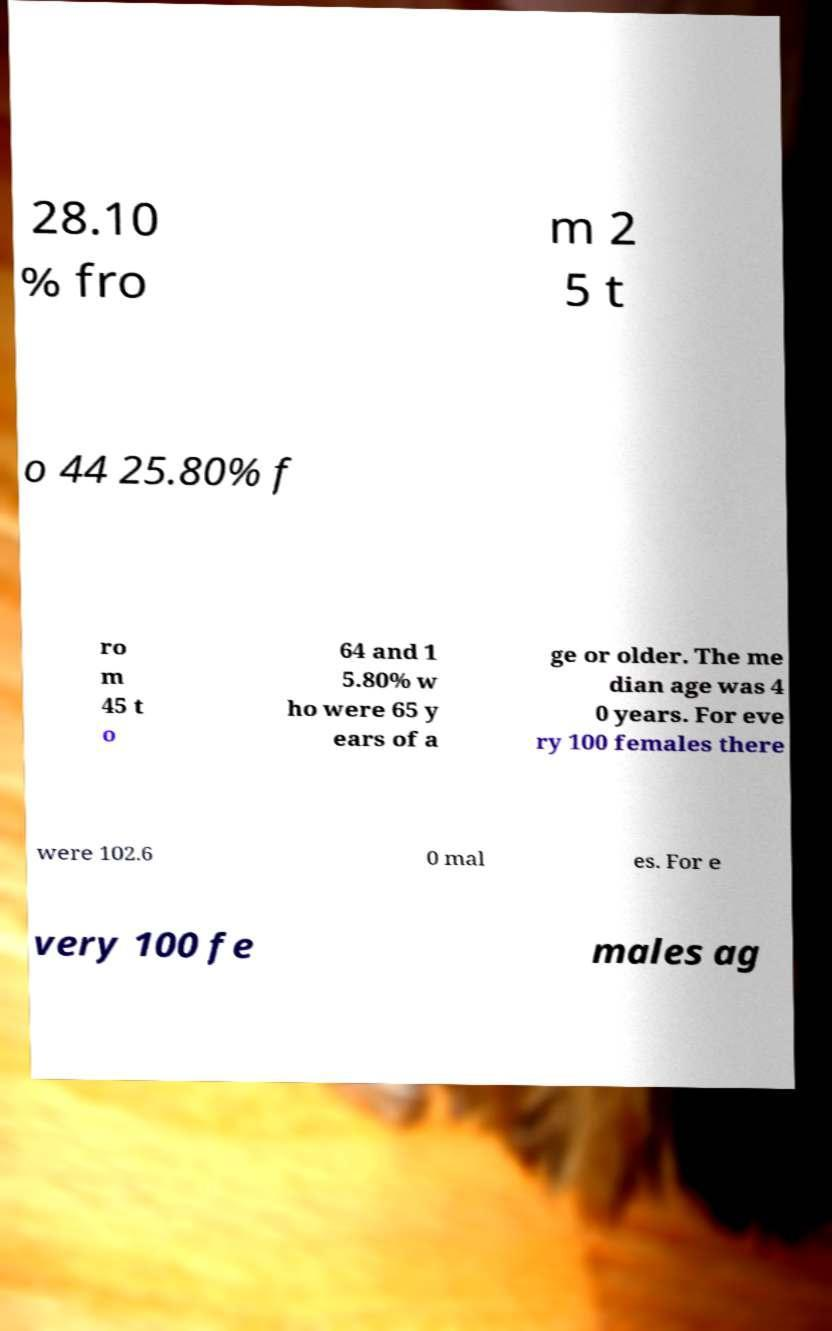Please read and relay the text visible in this image. What does it say? 28.10 % fro m 2 5 t o 44 25.80% f ro m 45 t o 64 and 1 5.80% w ho were 65 y ears of a ge or older. The me dian age was 4 0 years. For eve ry 100 females there were 102.6 0 mal es. For e very 100 fe males ag 